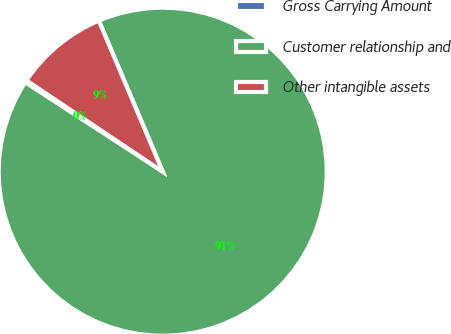Convert chart to OTSL. <chart><loc_0><loc_0><loc_500><loc_500><pie_chart><fcel>Gross Carrying Amount<fcel>Customer relationship and<fcel>Other intangible assets<nl><fcel>0.21%<fcel>90.55%<fcel>9.24%<nl></chart> 